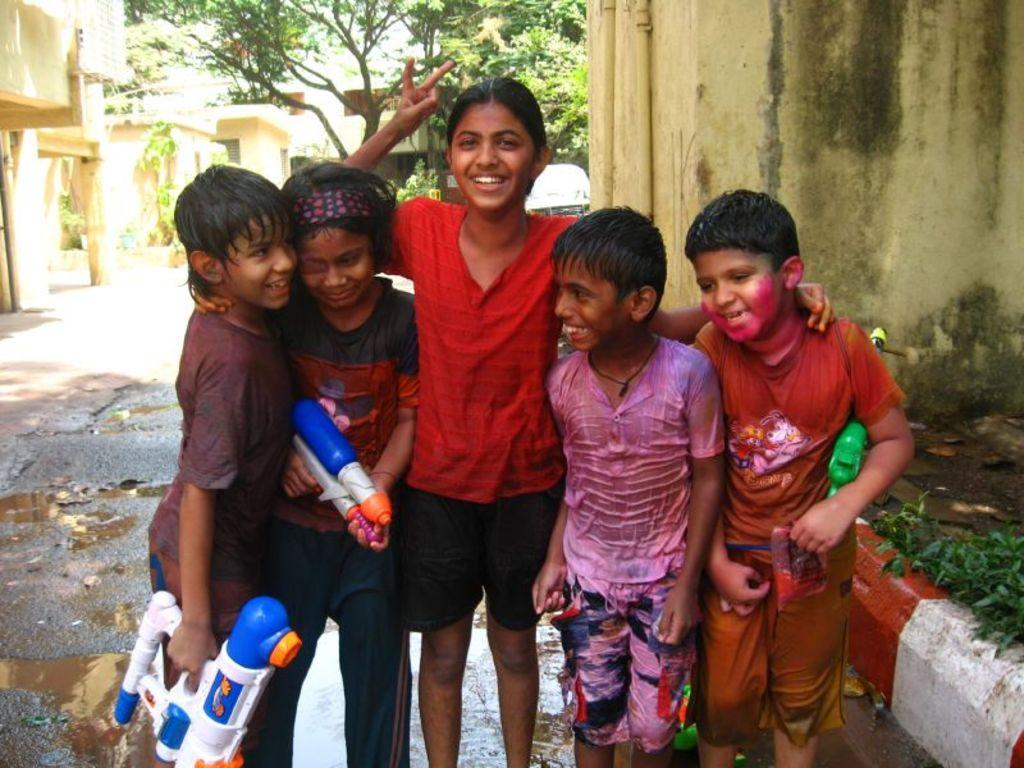How many people are present in the image? There are five people in the image. What is the facial expression of the people in the image? The people are smiling. What can be seen in the background of the image? There are buildings, trees, and a vehicle in the background of the image. Who is the creator of the trees in the background of the image? The image does not provide information about the creator of the trees; they are a natural part of the environment. 